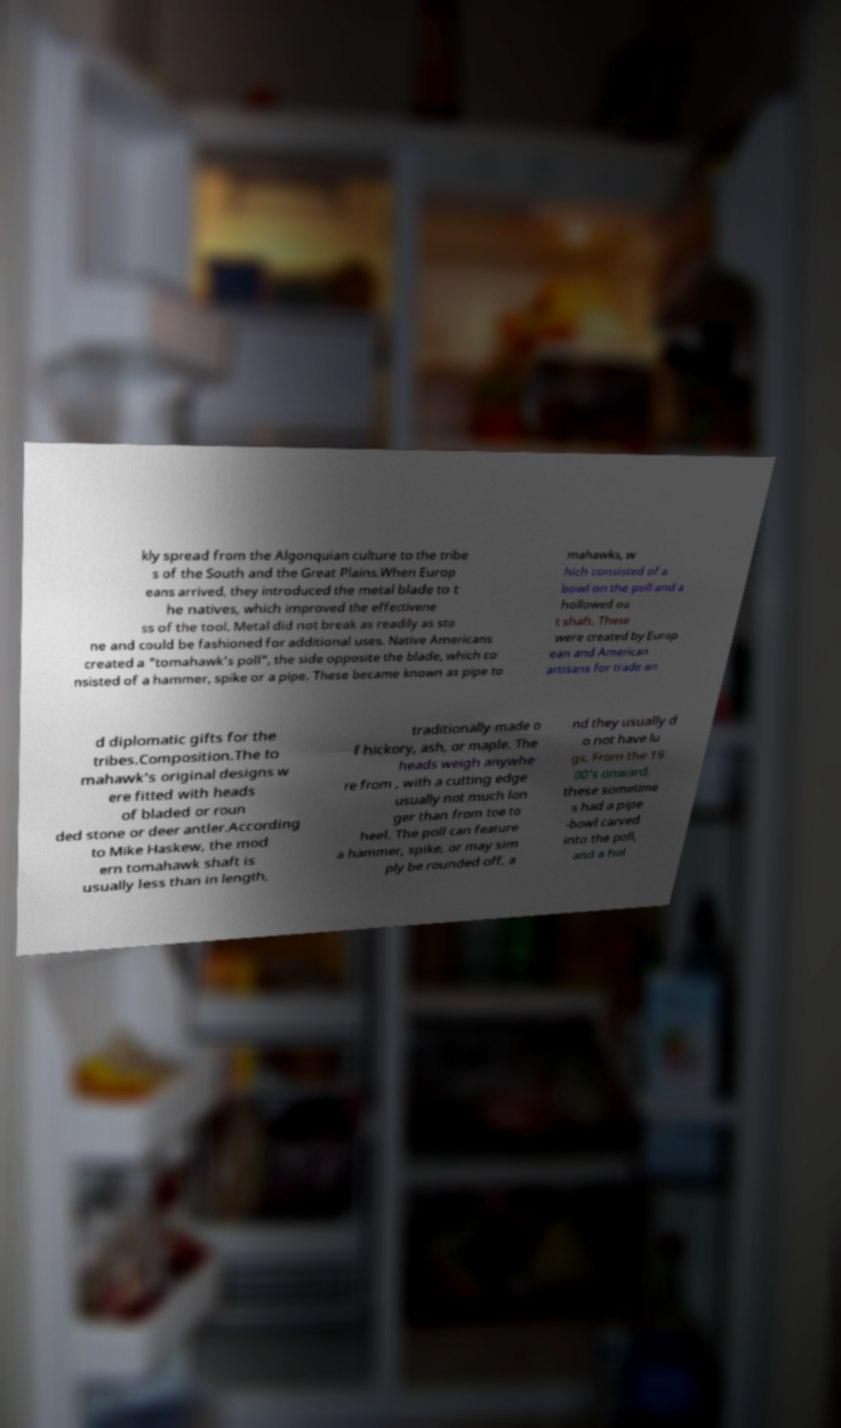There's text embedded in this image that I need extracted. Can you transcribe it verbatim? kly spread from the Algonquian culture to the tribe s of the South and the Great Plains.When Europ eans arrived, they introduced the metal blade to t he natives, which improved the effectivene ss of the tool. Metal did not break as readily as sto ne and could be fashioned for additional uses. Native Americans created a "tomahawk’s poll", the side opposite the blade, which co nsisted of a hammer, spike or a pipe. These became known as pipe to mahawks, w hich consisted of a bowl on the poll and a hollowed ou t shaft. These were created by Europ ean and American artisans for trade an d diplomatic gifts for the tribes.Composition.The to mahawk's original designs w ere fitted with heads of bladed or roun ded stone or deer antler.According to Mike Haskew, the mod ern tomahawk shaft is usually less than in length, traditionally made o f hickory, ash, or maple. The heads weigh anywhe re from , with a cutting edge usually not much lon ger than from toe to heel. The poll can feature a hammer, spike, or may sim ply be rounded off, a nd they usually d o not have lu gs. From the 19 00's onward, these sometime s had a pipe -bowl carved into the poll, and a hol 